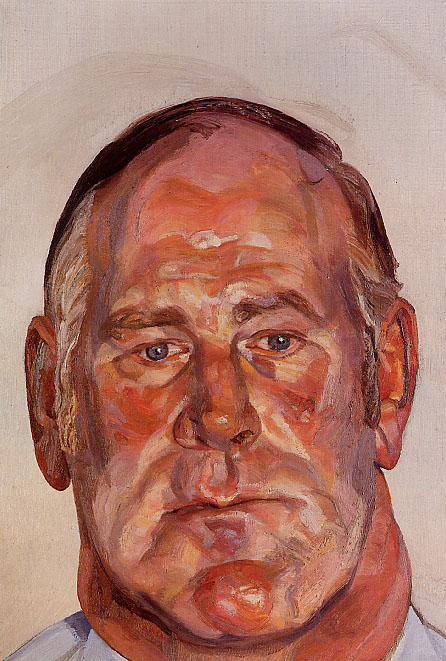What is this photo about? The image portrays a powerful and evocative portrait of a man. This painting employs an expressionist style, utilizing oil on canvas to create a rich and textured surface. The focus is on the man's face, which is depicted in a three-quarter view that occupies most of the canvas. His eyes are closed, which might suggest a moment of deep introspection or tranquility. 

The artwork's color palette predominantly features warm tones such as orange, red, and pink. These colors are applied with thick, textured brushstrokes that are typical of expressionist art, contrasting vividly with the pale beige background and bringing the man's face into sharp focus. The loose brushwork adds a dynamic quality to the painting. Overall, the artwork captures a moment of serene reflection, expressed through vivid colors and bold brushstrokes that are quintessential to the expressionist movement. 